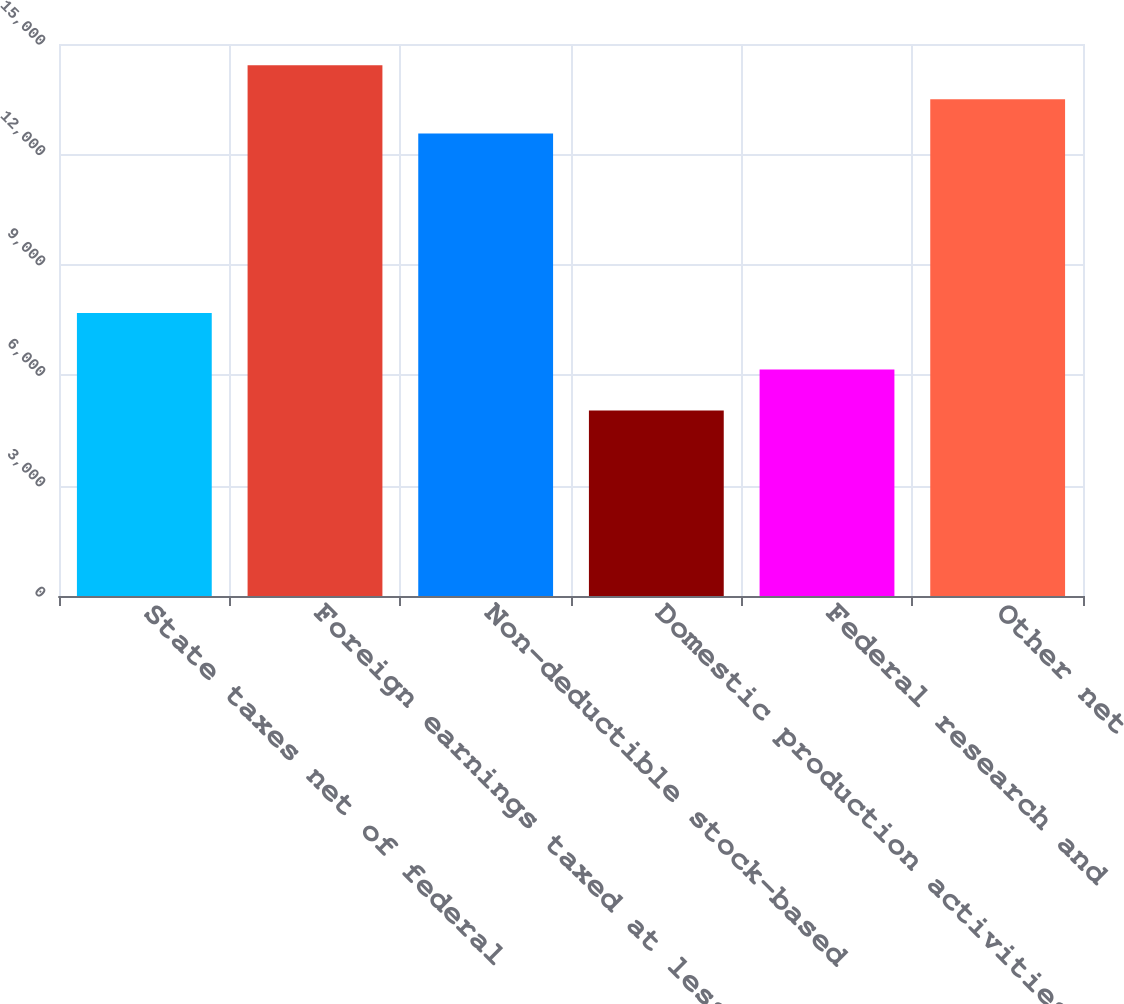Convert chart. <chart><loc_0><loc_0><loc_500><loc_500><bar_chart><fcel>State taxes net of federal<fcel>Foreign earnings taxed at less<fcel>Non-deductible stock-based<fcel>Domestic production activities<fcel>Federal research and<fcel>Other net<nl><fcel>7690<fcel>14422.8<fcel>12570<fcel>5040<fcel>6156<fcel>13496.4<nl></chart> 